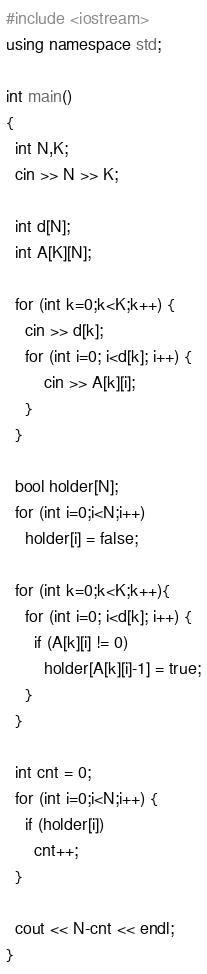Convert code to text. <code><loc_0><loc_0><loc_500><loc_500><_C++_>#include <iostream>
using namespace std;

int main()
{
  int N,K;
  cin >> N >> K;
  
  int d[N];
  int A[K][N];
  
  for (int k=0;k<K;k++) {
    cin >> d[k];
    for (int i=0; i<d[k]; i++) {
		cin >> A[k][i];
    }
  }
  
  bool holder[N];
  for (int i=0;i<N;i++)
    holder[i] = false;
  
  for (int k=0;k<K;k++){
    for (int i=0; i<d[k]; i++) {
      if (A[k][i] != 0)
       	holder[A[k][i]-1] = true;
    }
  }

  int cnt = 0;
  for (int i=0;i<N;i++) {
    if (holder[i])
      cnt++;
  }
  
  cout << N-cnt << endl;
}</code> 